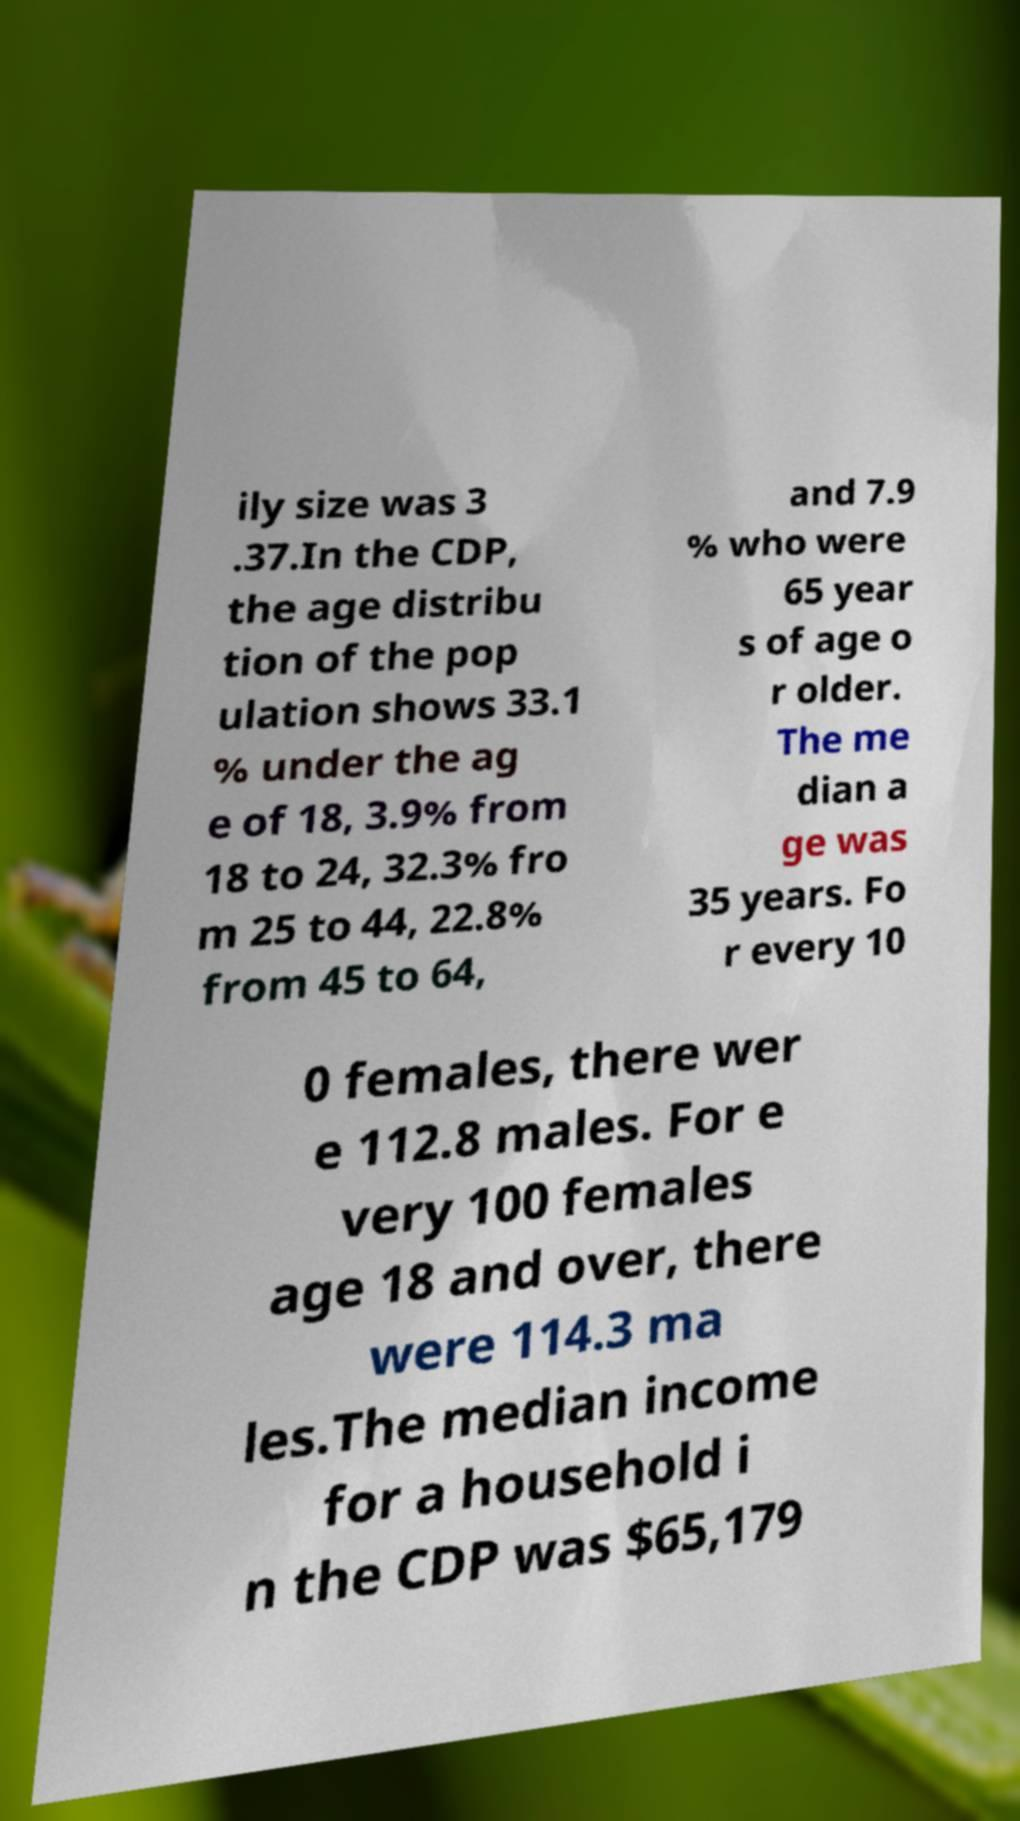I need the written content from this picture converted into text. Can you do that? ily size was 3 .37.In the CDP, the age distribu tion of the pop ulation shows 33.1 % under the ag e of 18, 3.9% from 18 to 24, 32.3% fro m 25 to 44, 22.8% from 45 to 64, and 7.9 % who were 65 year s of age o r older. The me dian a ge was 35 years. Fo r every 10 0 females, there wer e 112.8 males. For e very 100 females age 18 and over, there were 114.3 ma les.The median income for a household i n the CDP was $65,179 